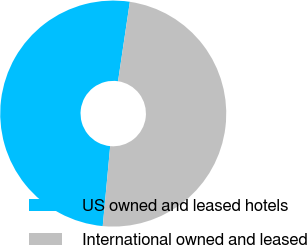Convert chart to OTSL. <chart><loc_0><loc_0><loc_500><loc_500><pie_chart><fcel>US owned and leased hotels<fcel>International owned and leased<nl><fcel>50.87%<fcel>49.13%<nl></chart> 